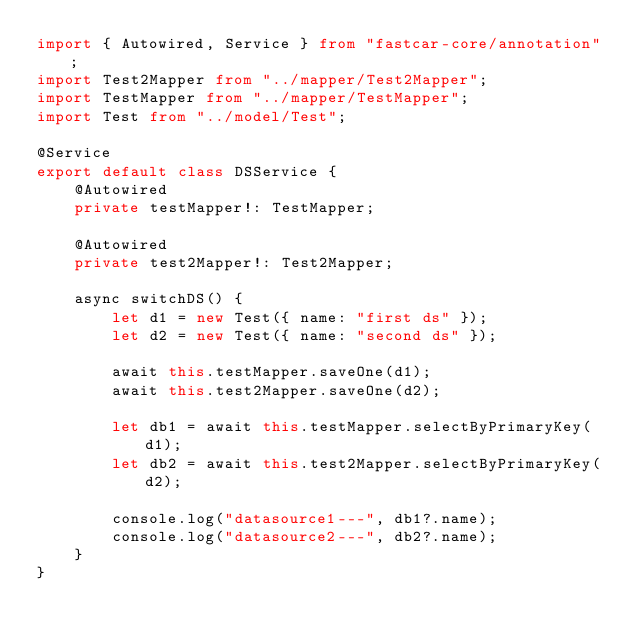<code> <loc_0><loc_0><loc_500><loc_500><_TypeScript_>import { Autowired, Service } from "fastcar-core/annotation";
import Test2Mapper from "../mapper/Test2Mapper";
import TestMapper from "../mapper/TestMapper";
import Test from "../model/Test";

@Service
export default class DSService {
	@Autowired
	private testMapper!: TestMapper;

	@Autowired
	private test2Mapper!: Test2Mapper;

	async switchDS() {
		let d1 = new Test({ name: "first ds" });
		let d2 = new Test({ name: "second ds" });

		await this.testMapper.saveOne(d1);
		await this.test2Mapper.saveOne(d2);

		let db1 = await this.testMapper.selectByPrimaryKey(d1);
		let db2 = await this.test2Mapper.selectByPrimaryKey(d2);

		console.log("datasource1---", db1?.name);
		console.log("datasource2---", db2?.name);
	}
}
</code> 